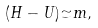<formula> <loc_0><loc_0><loc_500><loc_500>( H - U ) { \simeq } m ,</formula> 